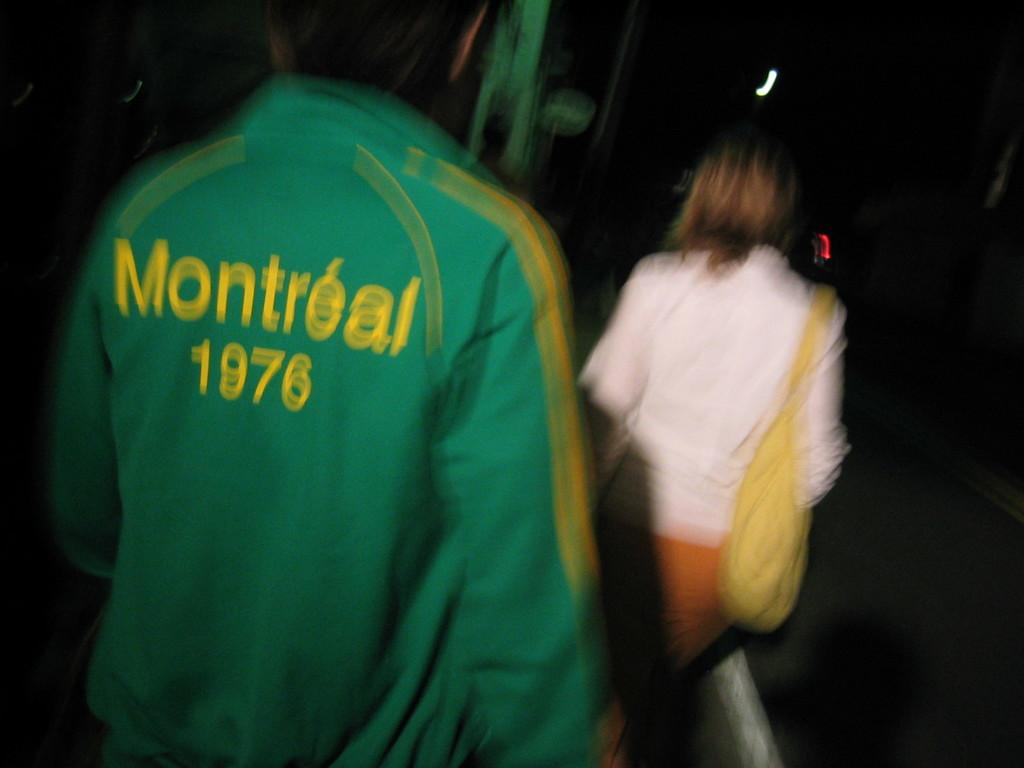Provide a one-sentence caption for the provided image. A green jacket with yellow lettering that says. Montreal 1976. 